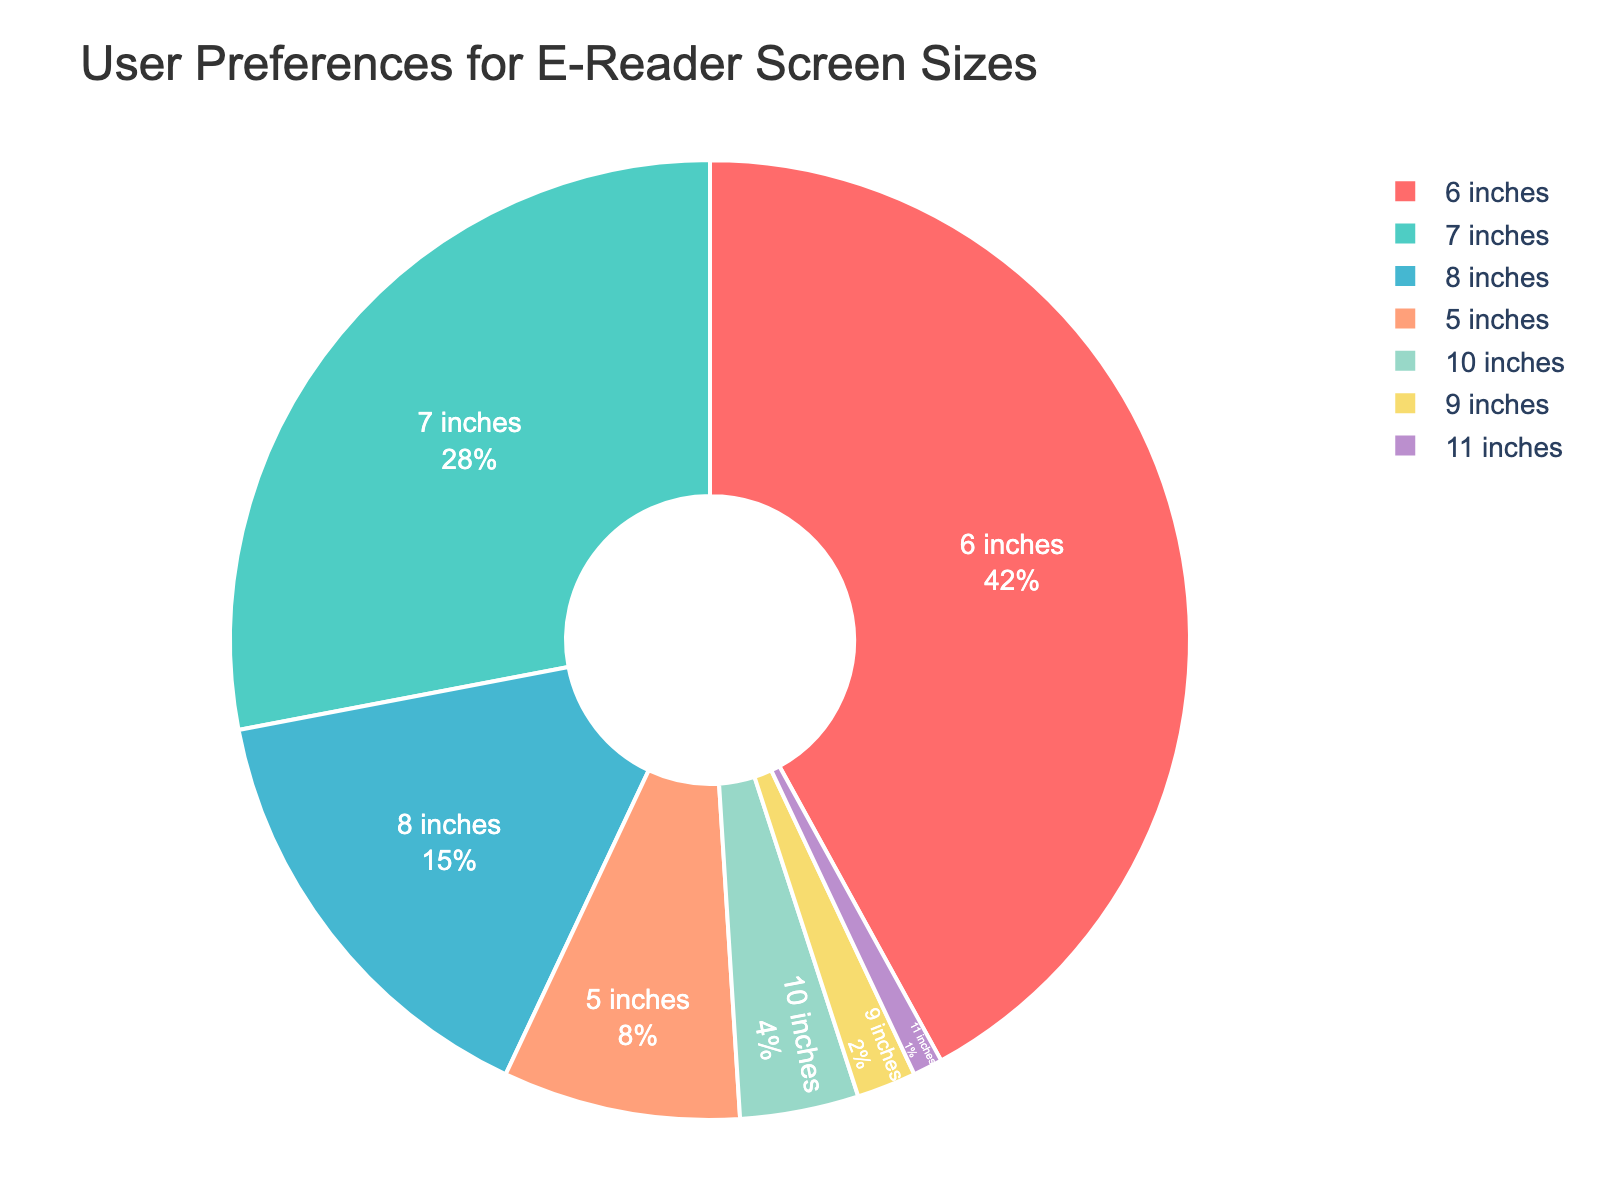Which screen size is preferred by the majority of users? The figure shows a pie chart with different segments representing screen sizes. The largest segment, colored red, corresponds to the 6 inches size, with 42%. Thus, the majority of users prefer the 6 inches screen size.
Answer: 6 inches What is the combined preference percentage for the 7 inches and 8 inches screen sizes? To find the combined preference, add the percentages for the 7 inches and 8 inches screen sizes. The figure shows 28% for 7 inches and 15% for 8 inches. Therefore, the combined preference is 28% + 15% = 43%.
Answer: 43% How does the preference for the 6 inches screen size compare to that for the 5 inches screen size? The figure shows that the 6 inches screen size has a preference of 42%, while the 5 inches screen size has 8%. By comparing these values, 6 inches is preferred significantly more than 5 inches (42% vs. 8%).
Answer: 6 inches is preferred more Which screen size has the smallest user preference percentage? The segment colored purple represents the 11 inches screen size, which has the smallest percentage at 1%. Thus, the 11 inches screen size has the smallest user preference.
Answer: 11 inches What is the difference in preference percentage between the most preferred (6 inches) and the least preferred (11 inches) screen sizes? The figure shows that the 6 inches screen size has 42% preference, and the 11 inches screen size has 1%. Subtract 1% from 42% to find the difference: 42% - 1% = 41%.
Answer: 41% What percentage of users prefer screen sizes smaller than 6 inches? The screen sizes smaller than 6 inches are 5 inches, indicated by the orange segment with 8%. Therefore, 8% of users prefer screen sizes smaller than 6 inches.
Answer: 8% What is the total preference percentage for screen sizes larger than 8 inches? To find the total, add the percentages for screen sizes 9 inches (2%), 10 inches (4%), and 11 inches (1%). Thus, the total preference for screen sizes larger than 8 inches is 2% + 4% + 1% = 7%.
Answer: 7% What is the average preference percentage for all the screen sizes combined? To calculate the average, sum all the preference percentages (42% + 28% + 15% + 8% + 4% + 2% + 1% = 100%) and then divide by the number of screen sizes (7). The average preference percentage is 100% / 7 = 14.3%.
Answer: 14.3% Is there a significant preference difference between 7 inches and 8 inches screen sizes? The pie chart shows 28% for 7 inches and 15% for 8 inches. The difference is 28% - 15% = 13%, indicating there is a notable preference difference between the two screen sizes.
Answer: 13% 